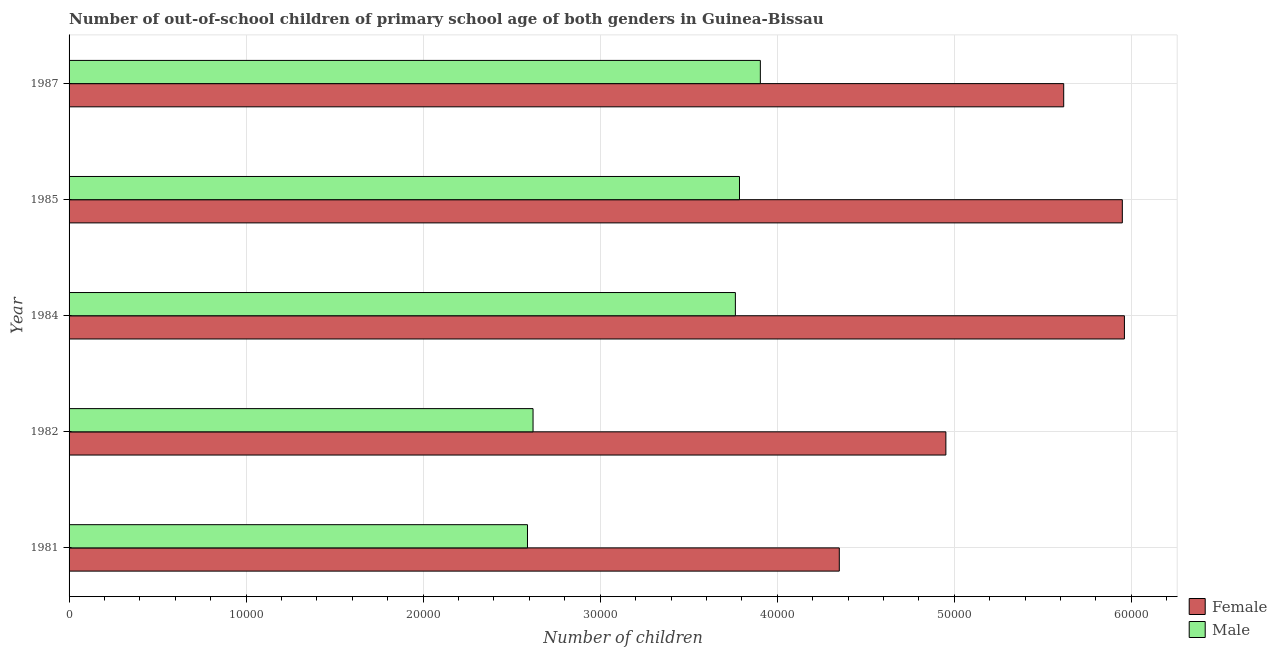How many different coloured bars are there?
Your answer should be compact. 2. How many groups of bars are there?
Your answer should be very brief. 5. Are the number of bars per tick equal to the number of legend labels?
Offer a terse response. Yes. How many bars are there on the 5th tick from the top?
Ensure brevity in your answer.  2. What is the label of the 3rd group of bars from the top?
Provide a succinct answer. 1984. What is the number of female out-of-school students in 1984?
Provide a succinct answer. 5.96e+04. Across all years, what is the maximum number of female out-of-school students?
Your answer should be very brief. 5.96e+04. Across all years, what is the minimum number of male out-of-school students?
Provide a short and direct response. 2.59e+04. In which year was the number of female out-of-school students minimum?
Provide a succinct answer. 1981. What is the total number of male out-of-school students in the graph?
Keep it short and to the point. 1.67e+05. What is the difference between the number of male out-of-school students in 1981 and that in 1984?
Ensure brevity in your answer.  -1.17e+04. What is the difference between the number of female out-of-school students in 1984 and the number of male out-of-school students in 1987?
Ensure brevity in your answer.  2.06e+04. What is the average number of male out-of-school students per year?
Offer a very short reply. 3.33e+04. In the year 1987, what is the difference between the number of female out-of-school students and number of male out-of-school students?
Your answer should be compact. 1.71e+04. Is the number of female out-of-school students in 1985 less than that in 1987?
Give a very brief answer. No. Is the difference between the number of female out-of-school students in 1984 and 1987 greater than the difference between the number of male out-of-school students in 1984 and 1987?
Offer a very short reply. Yes. What is the difference between the highest and the second highest number of male out-of-school students?
Provide a short and direct response. 1178. What is the difference between the highest and the lowest number of male out-of-school students?
Ensure brevity in your answer.  1.32e+04. Is the sum of the number of male out-of-school students in 1981 and 1982 greater than the maximum number of female out-of-school students across all years?
Provide a short and direct response. No. How many years are there in the graph?
Offer a terse response. 5. What is the difference between two consecutive major ticks on the X-axis?
Ensure brevity in your answer.  10000. How many legend labels are there?
Give a very brief answer. 2. What is the title of the graph?
Your answer should be very brief. Number of out-of-school children of primary school age of both genders in Guinea-Bissau. Does "Mobile cellular" appear as one of the legend labels in the graph?
Make the answer very short. No. What is the label or title of the X-axis?
Ensure brevity in your answer.  Number of children. What is the label or title of the Y-axis?
Offer a very short reply. Year. What is the Number of children of Female in 1981?
Provide a short and direct response. 4.35e+04. What is the Number of children in Male in 1981?
Ensure brevity in your answer.  2.59e+04. What is the Number of children of Female in 1982?
Provide a succinct answer. 4.95e+04. What is the Number of children in Male in 1982?
Your response must be concise. 2.62e+04. What is the Number of children in Female in 1984?
Ensure brevity in your answer.  5.96e+04. What is the Number of children in Male in 1984?
Keep it short and to the point. 3.76e+04. What is the Number of children of Female in 1985?
Provide a succinct answer. 5.95e+04. What is the Number of children of Male in 1985?
Provide a succinct answer. 3.79e+04. What is the Number of children in Female in 1987?
Offer a very short reply. 5.62e+04. What is the Number of children in Male in 1987?
Your response must be concise. 3.90e+04. Across all years, what is the maximum Number of children in Female?
Keep it short and to the point. 5.96e+04. Across all years, what is the maximum Number of children of Male?
Provide a succinct answer. 3.90e+04. Across all years, what is the minimum Number of children in Female?
Your answer should be very brief. 4.35e+04. Across all years, what is the minimum Number of children in Male?
Offer a terse response. 2.59e+04. What is the total Number of children of Female in the graph?
Provide a short and direct response. 2.68e+05. What is the total Number of children of Male in the graph?
Keep it short and to the point. 1.67e+05. What is the difference between the Number of children of Female in 1981 and that in 1982?
Provide a short and direct response. -6020. What is the difference between the Number of children of Male in 1981 and that in 1982?
Your response must be concise. -314. What is the difference between the Number of children of Female in 1981 and that in 1984?
Provide a succinct answer. -1.61e+04. What is the difference between the Number of children in Male in 1981 and that in 1984?
Make the answer very short. -1.17e+04. What is the difference between the Number of children in Female in 1981 and that in 1985?
Offer a very short reply. -1.60e+04. What is the difference between the Number of children in Male in 1981 and that in 1985?
Your response must be concise. -1.20e+04. What is the difference between the Number of children in Female in 1981 and that in 1987?
Make the answer very short. -1.27e+04. What is the difference between the Number of children in Male in 1981 and that in 1987?
Provide a succinct answer. -1.32e+04. What is the difference between the Number of children in Female in 1982 and that in 1984?
Offer a terse response. -1.01e+04. What is the difference between the Number of children of Male in 1982 and that in 1984?
Provide a succinct answer. -1.14e+04. What is the difference between the Number of children in Female in 1982 and that in 1985?
Your answer should be very brief. -9966. What is the difference between the Number of children in Male in 1982 and that in 1985?
Offer a very short reply. -1.17e+04. What is the difference between the Number of children in Female in 1982 and that in 1987?
Give a very brief answer. -6655. What is the difference between the Number of children of Male in 1982 and that in 1987?
Your response must be concise. -1.28e+04. What is the difference between the Number of children in Female in 1984 and that in 1985?
Ensure brevity in your answer.  119. What is the difference between the Number of children of Male in 1984 and that in 1985?
Offer a terse response. -232. What is the difference between the Number of children of Female in 1984 and that in 1987?
Provide a short and direct response. 3430. What is the difference between the Number of children in Male in 1984 and that in 1987?
Your answer should be very brief. -1410. What is the difference between the Number of children of Female in 1985 and that in 1987?
Your answer should be very brief. 3311. What is the difference between the Number of children in Male in 1985 and that in 1987?
Make the answer very short. -1178. What is the difference between the Number of children of Female in 1981 and the Number of children of Male in 1982?
Provide a succinct answer. 1.73e+04. What is the difference between the Number of children in Female in 1981 and the Number of children in Male in 1984?
Give a very brief answer. 5870. What is the difference between the Number of children of Female in 1981 and the Number of children of Male in 1985?
Offer a very short reply. 5638. What is the difference between the Number of children in Female in 1981 and the Number of children in Male in 1987?
Keep it short and to the point. 4460. What is the difference between the Number of children in Female in 1982 and the Number of children in Male in 1984?
Ensure brevity in your answer.  1.19e+04. What is the difference between the Number of children of Female in 1982 and the Number of children of Male in 1985?
Provide a succinct answer. 1.17e+04. What is the difference between the Number of children of Female in 1982 and the Number of children of Male in 1987?
Make the answer very short. 1.05e+04. What is the difference between the Number of children in Female in 1984 and the Number of children in Male in 1985?
Your answer should be compact. 2.17e+04. What is the difference between the Number of children in Female in 1984 and the Number of children in Male in 1987?
Give a very brief answer. 2.06e+04. What is the difference between the Number of children of Female in 1985 and the Number of children of Male in 1987?
Your answer should be compact. 2.04e+04. What is the average Number of children in Female per year?
Keep it short and to the point. 5.37e+04. What is the average Number of children in Male per year?
Keep it short and to the point. 3.33e+04. In the year 1981, what is the difference between the Number of children in Female and Number of children in Male?
Provide a short and direct response. 1.76e+04. In the year 1982, what is the difference between the Number of children in Female and Number of children in Male?
Give a very brief answer. 2.33e+04. In the year 1984, what is the difference between the Number of children in Female and Number of children in Male?
Provide a succinct answer. 2.20e+04. In the year 1985, what is the difference between the Number of children of Female and Number of children of Male?
Your answer should be very brief. 2.16e+04. In the year 1987, what is the difference between the Number of children of Female and Number of children of Male?
Offer a terse response. 1.71e+04. What is the ratio of the Number of children in Female in 1981 to that in 1982?
Offer a terse response. 0.88. What is the ratio of the Number of children of Male in 1981 to that in 1982?
Your answer should be very brief. 0.99. What is the ratio of the Number of children in Female in 1981 to that in 1984?
Offer a very short reply. 0.73. What is the ratio of the Number of children of Male in 1981 to that in 1984?
Offer a very short reply. 0.69. What is the ratio of the Number of children of Female in 1981 to that in 1985?
Provide a succinct answer. 0.73. What is the ratio of the Number of children of Male in 1981 to that in 1985?
Your response must be concise. 0.68. What is the ratio of the Number of children in Female in 1981 to that in 1987?
Give a very brief answer. 0.77. What is the ratio of the Number of children of Male in 1981 to that in 1987?
Your answer should be compact. 0.66. What is the ratio of the Number of children in Female in 1982 to that in 1984?
Give a very brief answer. 0.83. What is the ratio of the Number of children of Male in 1982 to that in 1984?
Provide a short and direct response. 0.7. What is the ratio of the Number of children of Female in 1982 to that in 1985?
Your answer should be compact. 0.83. What is the ratio of the Number of children in Male in 1982 to that in 1985?
Make the answer very short. 0.69. What is the ratio of the Number of children in Female in 1982 to that in 1987?
Ensure brevity in your answer.  0.88. What is the ratio of the Number of children of Male in 1982 to that in 1987?
Offer a terse response. 0.67. What is the ratio of the Number of children of Female in 1984 to that in 1987?
Offer a terse response. 1.06. What is the ratio of the Number of children of Male in 1984 to that in 1987?
Provide a succinct answer. 0.96. What is the ratio of the Number of children of Female in 1985 to that in 1987?
Your response must be concise. 1.06. What is the ratio of the Number of children of Male in 1985 to that in 1987?
Your answer should be very brief. 0.97. What is the difference between the highest and the second highest Number of children in Female?
Keep it short and to the point. 119. What is the difference between the highest and the second highest Number of children of Male?
Offer a terse response. 1178. What is the difference between the highest and the lowest Number of children of Female?
Keep it short and to the point. 1.61e+04. What is the difference between the highest and the lowest Number of children of Male?
Your answer should be compact. 1.32e+04. 